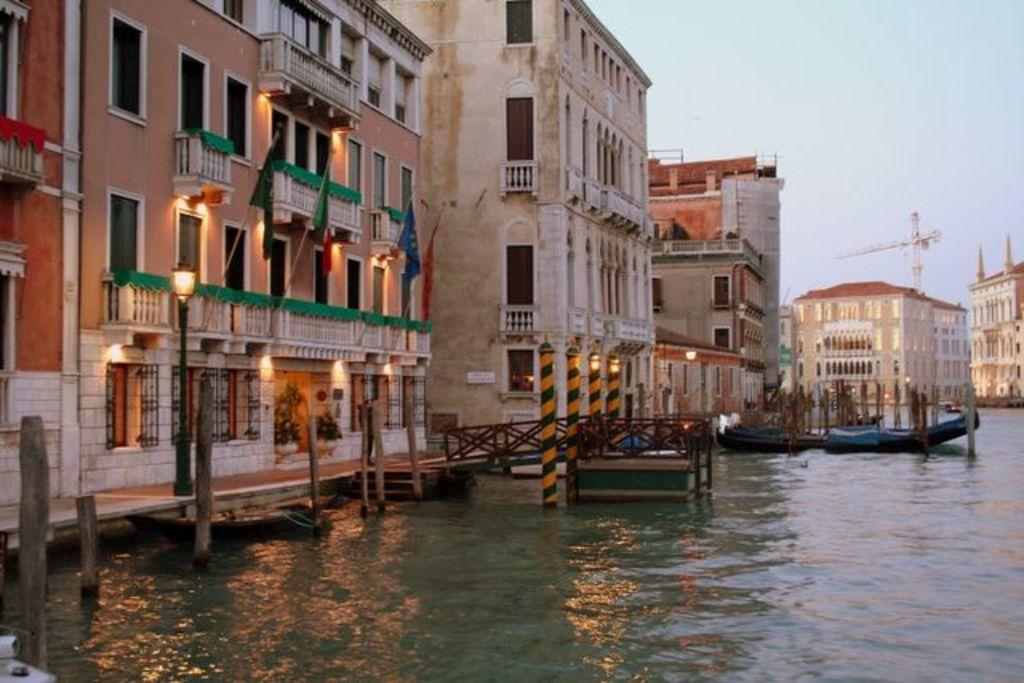In one or two sentences, can you explain what this image depicts? To the bottom of the image there is water. In the middle of the water there are boats. And to the left side on the water there are wooden poles. And to the left corner there is a building with windows, walls, pillars, balcony with green cloth and also there are flagpoles with flags. And in the background there are many buildings with walls, windows, balconies and pillars. To the right side of the image there is a building, behind the building there is a crane. And to the top right of the image there is a sky. 